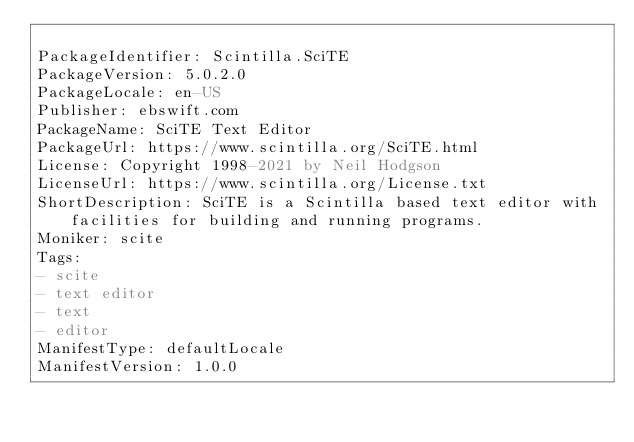Convert code to text. <code><loc_0><loc_0><loc_500><loc_500><_YAML_>
PackageIdentifier: Scintilla.SciTE
PackageVersion: 5.0.2.0
PackageLocale: en-US
Publisher: ebswift.com
PackageName: SciTE Text Editor
PackageUrl: https://www.scintilla.org/SciTE.html
License: Copyright 1998-2021 by Neil Hodgson
LicenseUrl: https://www.scintilla.org/License.txt
ShortDescription: SciTE is a Scintilla based text editor with facilities for building and running programs.
Moniker: scite
Tags:
- scite
- text editor
- text
- editor
ManifestType: defaultLocale
ManifestVersion: 1.0.0
</code> 